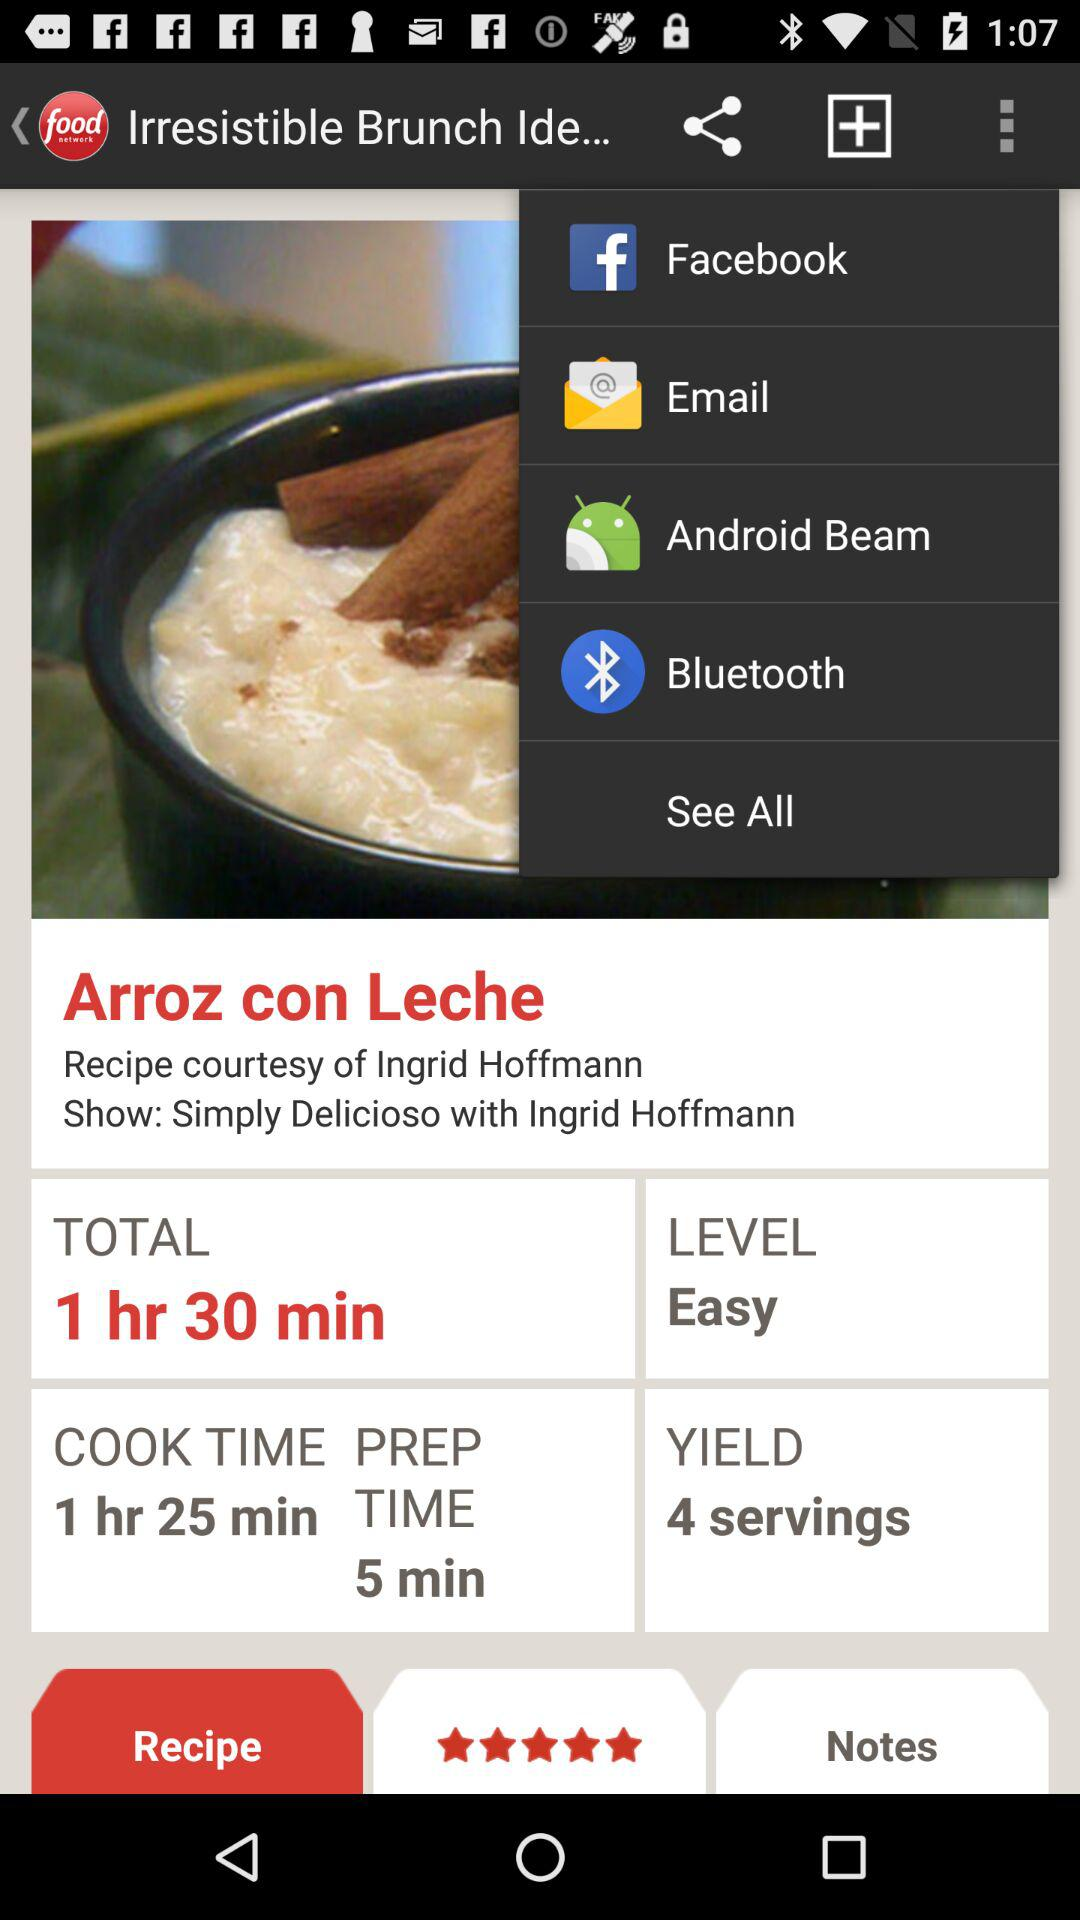What is the current level? The current level is easy. 